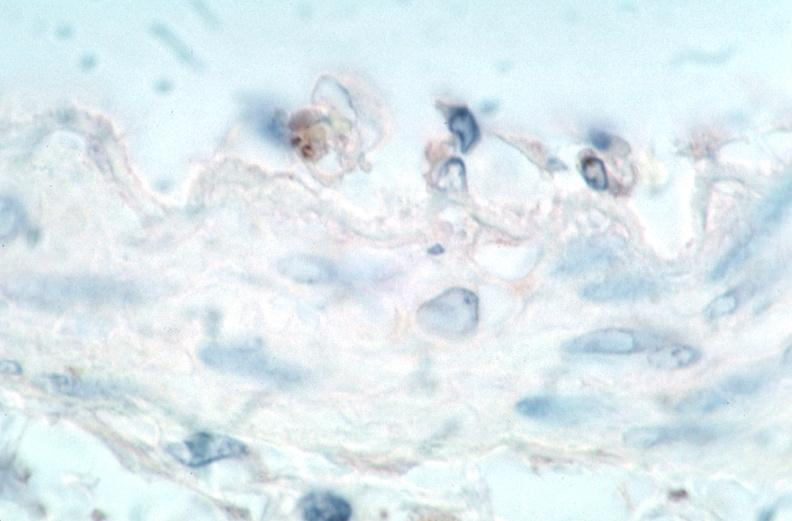what is present?
Answer the question using a single word or phrase. Cardiovascular 